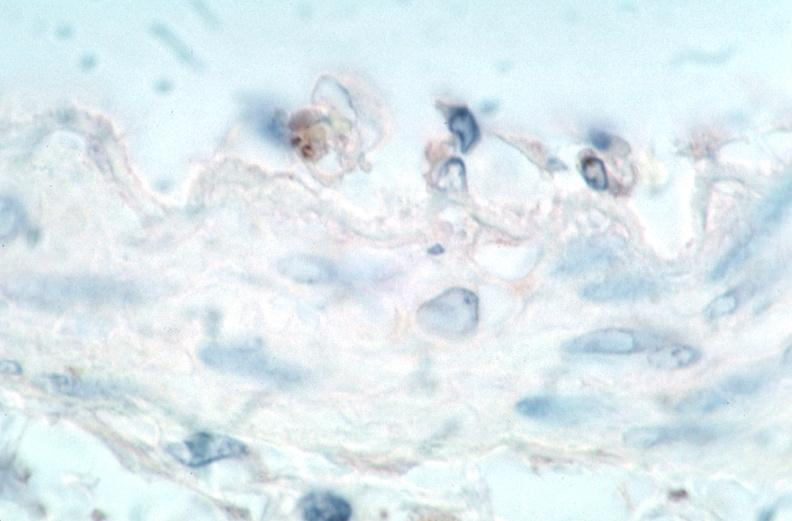what is present?
Answer the question using a single word or phrase. Cardiovascular 